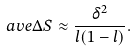Convert formula to latex. <formula><loc_0><loc_0><loc_500><loc_500>\ a v e { \Delta S } \approx \frac { \delta ^ { 2 } } { l ( 1 - l ) } .</formula> 